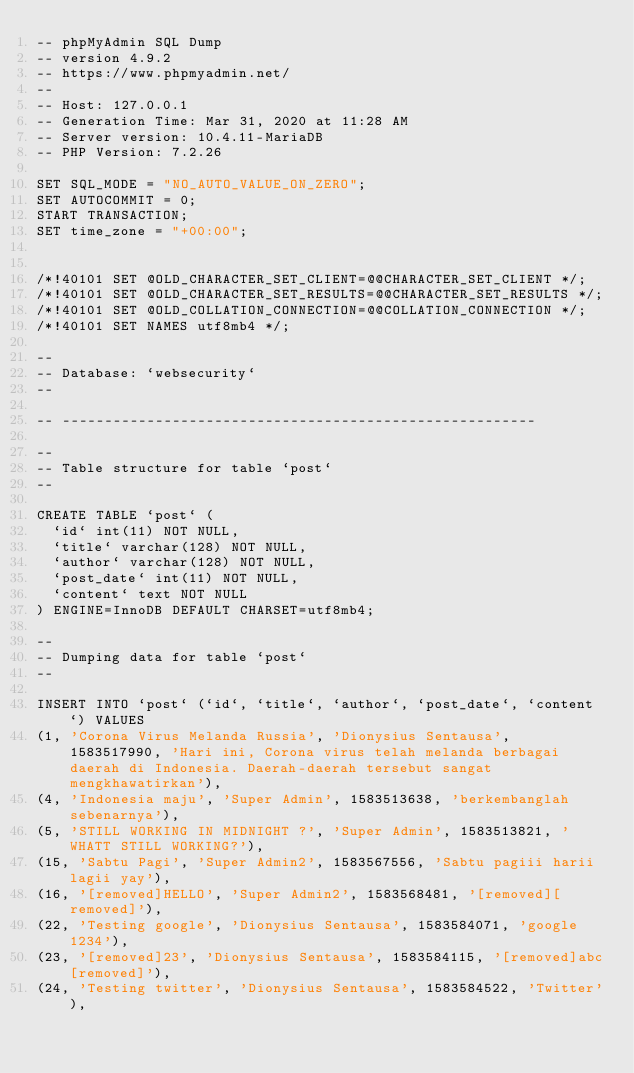<code> <loc_0><loc_0><loc_500><loc_500><_SQL_>-- phpMyAdmin SQL Dump
-- version 4.9.2
-- https://www.phpmyadmin.net/
--
-- Host: 127.0.0.1
-- Generation Time: Mar 31, 2020 at 11:28 AM
-- Server version: 10.4.11-MariaDB
-- PHP Version: 7.2.26

SET SQL_MODE = "NO_AUTO_VALUE_ON_ZERO";
SET AUTOCOMMIT = 0;
START TRANSACTION;
SET time_zone = "+00:00";


/*!40101 SET @OLD_CHARACTER_SET_CLIENT=@@CHARACTER_SET_CLIENT */;
/*!40101 SET @OLD_CHARACTER_SET_RESULTS=@@CHARACTER_SET_RESULTS */;
/*!40101 SET @OLD_COLLATION_CONNECTION=@@COLLATION_CONNECTION */;
/*!40101 SET NAMES utf8mb4 */;

--
-- Database: `websecurity`
--

-- --------------------------------------------------------

--
-- Table structure for table `post`
--

CREATE TABLE `post` (
  `id` int(11) NOT NULL,
  `title` varchar(128) NOT NULL,
  `author` varchar(128) NOT NULL,
  `post_date` int(11) NOT NULL,
  `content` text NOT NULL
) ENGINE=InnoDB DEFAULT CHARSET=utf8mb4;

--
-- Dumping data for table `post`
--

INSERT INTO `post` (`id`, `title`, `author`, `post_date`, `content`) VALUES
(1, 'Corona Virus Melanda Russia', 'Dionysius Sentausa', 1583517990, 'Hari ini, Corona virus telah melanda berbagai daerah di Indonesia. Daerah-daerah tersebut sangat mengkhawatirkan'),
(4, 'Indonesia maju', 'Super Admin', 1583513638, 'berkembanglah sebenarnya'),
(5, 'STILL WORKING IN MIDNIGHT ?', 'Super Admin', 1583513821, 'WHATT STILL WORKING?'),
(15, 'Sabtu Pagi', 'Super Admin2', 1583567556, 'Sabtu pagiii harii lagii yay'),
(16, '[removed]HELLO', 'Super Admin2', 1583568481, '[removed][removed]'),
(22, 'Testing google', 'Dionysius Sentausa', 1583584071, 'google 1234'),
(23, '[removed]23', 'Dionysius Sentausa', 1583584115, '[removed]abc[removed]'),
(24, 'Testing twitter', 'Dionysius Sentausa', 1583584522, 'Twitter'),</code> 